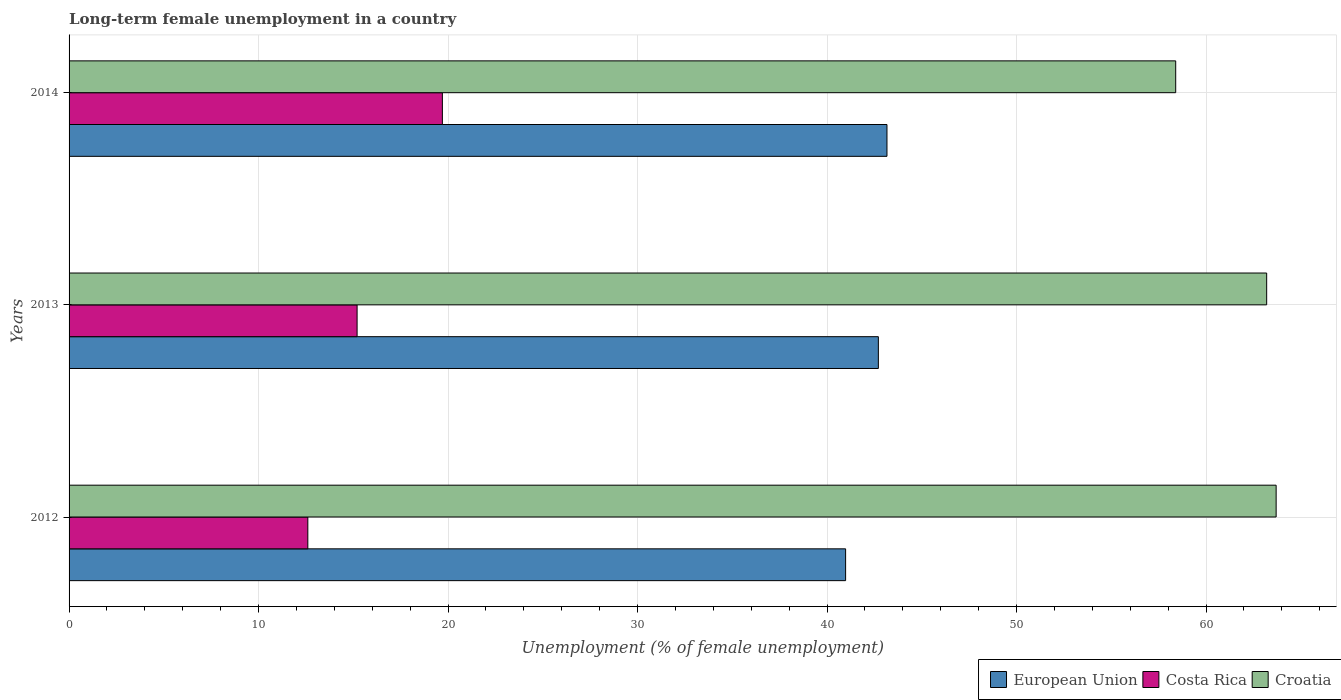How many different coloured bars are there?
Provide a short and direct response. 3. Are the number of bars per tick equal to the number of legend labels?
Provide a short and direct response. Yes. How many bars are there on the 1st tick from the top?
Your answer should be compact. 3. How many bars are there on the 3rd tick from the bottom?
Give a very brief answer. 3. What is the percentage of long-term unemployed female population in Croatia in 2014?
Make the answer very short. 58.4. Across all years, what is the maximum percentage of long-term unemployed female population in Costa Rica?
Provide a succinct answer. 19.7. Across all years, what is the minimum percentage of long-term unemployed female population in Costa Rica?
Provide a succinct answer. 12.6. In which year was the percentage of long-term unemployed female population in European Union maximum?
Offer a very short reply. 2014. What is the total percentage of long-term unemployed female population in Costa Rica in the graph?
Offer a very short reply. 47.5. What is the difference between the percentage of long-term unemployed female population in European Union in 2012 and that in 2013?
Provide a succinct answer. -1.73. What is the difference between the percentage of long-term unemployed female population in European Union in 2013 and the percentage of long-term unemployed female population in Croatia in 2012?
Your answer should be very brief. -20.99. What is the average percentage of long-term unemployed female population in European Union per year?
Provide a succinct answer. 42.28. In the year 2013, what is the difference between the percentage of long-term unemployed female population in Croatia and percentage of long-term unemployed female population in European Union?
Make the answer very short. 20.49. In how many years, is the percentage of long-term unemployed female population in Costa Rica greater than 2 %?
Offer a terse response. 3. What is the ratio of the percentage of long-term unemployed female population in European Union in 2012 to that in 2014?
Offer a terse response. 0.95. Is the percentage of long-term unemployed female population in Croatia in 2012 less than that in 2014?
Make the answer very short. No. Is the difference between the percentage of long-term unemployed female population in Croatia in 2012 and 2014 greater than the difference between the percentage of long-term unemployed female population in European Union in 2012 and 2014?
Your answer should be very brief. Yes. What is the difference between the highest and the second highest percentage of long-term unemployed female population in Costa Rica?
Give a very brief answer. 4.5. What is the difference between the highest and the lowest percentage of long-term unemployed female population in European Union?
Make the answer very short. 2.18. What does the 3rd bar from the top in 2013 represents?
Provide a short and direct response. European Union. Is it the case that in every year, the sum of the percentage of long-term unemployed female population in Croatia and percentage of long-term unemployed female population in European Union is greater than the percentage of long-term unemployed female population in Costa Rica?
Provide a succinct answer. Yes. What is the difference between two consecutive major ticks on the X-axis?
Offer a very short reply. 10. Does the graph contain any zero values?
Provide a succinct answer. No. Where does the legend appear in the graph?
Keep it short and to the point. Bottom right. How many legend labels are there?
Make the answer very short. 3. How are the legend labels stacked?
Make the answer very short. Horizontal. What is the title of the graph?
Provide a succinct answer. Long-term female unemployment in a country. Does "American Samoa" appear as one of the legend labels in the graph?
Offer a terse response. No. What is the label or title of the X-axis?
Keep it short and to the point. Unemployment (% of female unemployment). What is the Unemployment (% of female unemployment) in European Union in 2012?
Offer a very short reply. 40.98. What is the Unemployment (% of female unemployment) of Costa Rica in 2012?
Offer a very short reply. 12.6. What is the Unemployment (% of female unemployment) in Croatia in 2012?
Give a very brief answer. 63.7. What is the Unemployment (% of female unemployment) in European Union in 2013?
Provide a succinct answer. 42.71. What is the Unemployment (% of female unemployment) in Costa Rica in 2013?
Provide a succinct answer. 15.2. What is the Unemployment (% of female unemployment) of Croatia in 2013?
Ensure brevity in your answer.  63.2. What is the Unemployment (% of female unemployment) of European Union in 2014?
Provide a succinct answer. 43.16. What is the Unemployment (% of female unemployment) of Costa Rica in 2014?
Offer a terse response. 19.7. What is the Unemployment (% of female unemployment) in Croatia in 2014?
Your answer should be very brief. 58.4. Across all years, what is the maximum Unemployment (% of female unemployment) of European Union?
Your answer should be very brief. 43.16. Across all years, what is the maximum Unemployment (% of female unemployment) of Costa Rica?
Keep it short and to the point. 19.7. Across all years, what is the maximum Unemployment (% of female unemployment) in Croatia?
Give a very brief answer. 63.7. Across all years, what is the minimum Unemployment (% of female unemployment) in European Union?
Provide a succinct answer. 40.98. Across all years, what is the minimum Unemployment (% of female unemployment) in Costa Rica?
Provide a succinct answer. 12.6. Across all years, what is the minimum Unemployment (% of female unemployment) in Croatia?
Your response must be concise. 58.4. What is the total Unemployment (% of female unemployment) of European Union in the graph?
Keep it short and to the point. 126.85. What is the total Unemployment (% of female unemployment) of Costa Rica in the graph?
Offer a terse response. 47.5. What is the total Unemployment (% of female unemployment) in Croatia in the graph?
Provide a short and direct response. 185.3. What is the difference between the Unemployment (% of female unemployment) in European Union in 2012 and that in 2013?
Provide a short and direct response. -1.73. What is the difference between the Unemployment (% of female unemployment) of Costa Rica in 2012 and that in 2013?
Ensure brevity in your answer.  -2.6. What is the difference between the Unemployment (% of female unemployment) of European Union in 2012 and that in 2014?
Your response must be concise. -2.18. What is the difference between the Unemployment (% of female unemployment) in Costa Rica in 2012 and that in 2014?
Offer a terse response. -7.1. What is the difference between the Unemployment (% of female unemployment) of Croatia in 2012 and that in 2014?
Give a very brief answer. 5.3. What is the difference between the Unemployment (% of female unemployment) in European Union in 2013 and that in 2014?
Offer a very short reply. -0.45. What is the difference between the Unemployment (% of female unemployment) in Costa Rica in 2013 and that in 2014?
Offer a terse response. -4.5. What is the difference between the Unemployment (% of female unemployment) in Croatia in 2013 and that in 2014?
Provide a short and direct response. 4.8. What is the difference between the Unemployment (% of female unemployment) of European Union in 2012 and the Unemployment (% of female unemployment) of Costa Rica in 2013?
Your answer should be very brief. 25.78. What is the difference between the Unemployment (% of female unemployment) of European Union in 2012 and the Unemployment (% of female unemployment) of Croatia in 2013?
Offer a terse response. -22.22. What is the difference between the Unemployment (% of female unemployment) of Costa Rica in 2012 and the Unemployment (% of female unemployment) of Croatia in 2013?
Offer a terse response. -50.6. What is the difference between the Unemployment (% of female unemployment) in European Union in 2012 and the Unemployment (% of female unemployment) in Costa Rica in 2014?
Provide a succinct answer. 21.28. What is the difference between the Unemployment (% of female unemployment) of European Union in 2012 and the Unemployment (% of female unemployment) of Croatia in 2014?
Provide a short and direct response. -17.42. What is the difference between the Unemployment (% of female unemployment) of Costa Rica in 2012 and the Unemployment (% of female unemployment) of Croatia in 2014?
Your answer should be compact. -45.8. What is the difference between the Unemployment (% of female unemployment) in European Union in 2013 and the Unemployment (% of female unemployment) in Costa Rica in 2014?
Offer a terse response. 23.01. What is the difference between the Unemployment (% of female unemployment) in European Union in 2013 and the Unemployment (% of female unemployment) in Croatia in 2014?
Your response must be concise. -15.69. What is the difference between the Unemployment (% of female unemployment) in Costa Rica in 2013 and the Unemployment (% of female unemployment) in Croatia in 2014?
Make the answer very short. -43.2. What is the average Unemployment (% of female unemployment) in European Union per year?
Your answer should be very brief. 42.28. What is the average Unemployment (% of female unemployment) in Costa Rica per year?
Offer a very short reply. 15.83. What is the average Unemployment (% of female unemployment) of Croatia per year?
Your answer should be compact. 61.77. In the year 2012, what is the difference between the Unemployment (% of female unemployment) in European Union and Unemployment (% of female unemployment) in Costa Rica?
Provide a short and direct response. 28.38. In the year 2012, what is the difference between the Unemployment (% of female unemployment) in European Union and Unemployment (% of female unemployment) in Croatia?
Your answer should be very brief. -22.72. In the year 2012, what is the difference between the Unemployment (% of female unemployment) in Costa Rica and Unemployment (% of female unemployment) in Croatia?
Provide a short and direct response. -51.1. In the year 2013, what is the difference between the Unemployment (% of female unemployment) in European Union and Unemployment (% of female unemployment) in Costa Rica?
Ensure brevity in your answer.  27.51. In the year 2013, what is the difference between the Unemployment (% of female unemployment) of European Union and Unemployment (% of female unemployment) of Croatia?
Offer a terse response. -20.49. In the year 2013, what is the difference between the Unemployment (% of female unemployment) of Costa Rica and Unemployment (% of female unemployment) of Croatia?
Give a very brief answer. -48. In the year 2014, what is the difference between the Unemployment (% of female unemployment) of European Union and Unemployment (% of female unemployment) of Costa Rica?
Your answer should be very brief. 23.46. In the year 2014, what is the difference between the Unemployment (% of female unemployment) of European Union and Unemployment (% of female unemployment) of Croatia?
Offer a very short reply. -15.24. In the year 2014, what is the difference between the Unemployment (% of female unemployment) of Costa Rica and Unemployment (% of female unemployment) of Croatia?
Your answer should be compact. -38.7. What is the ratio of the Unemployment (% of female unemployment) in European Union in 2012 to that in 2013?
Keep it short and to the point. 0.96. What is the ratio of the Unemployment (% of female unemployment) of Costa Rica in 2012 to that in 2013?
Give a very brief answer. 0.83. What is the ratio of the Unemployment (% of female unemployment) in Croatia in 2012 to that in 2013?
Ensure brevity in your answer.  1.01. What is the ratio of the Unemployment (% of female unemployment) of European Union in 2012 to that in 2014?
Keep it short and to the point. 0.95. What is the ratio of the Unemployment (% of female unemployment) in Costa Rica in 2012 to that in 2014?
Offer a very short reply. 0.64. What is the ratio of the Unemployment (% of female unemployment) in Croatia in 2012 to that in 2014?
Ensure brevity in your answer.  1.09. What is the ratio of the Unemployment (% of female unemployment) of European Union in 2013 to that in 2014?
Your answer should be compact. 0.99. What is the ratio of the Unemployment (% of female unemployment) of Costa Rica in 2013 to that in 2014?
Provide a succinct answer. 0.77. What is the ratio of the Unemployment (% of female unemployment) of Croatia in 2013 to that in 2014?
Your answer should be very brief. 1.08. What is the difference between the highest and the second highest Unemployment (% of female unemployment) in European Union?
Offer a terse response. 0.45. What is the difference between the highest and the second highest Unemployment (% of female unemployment) of Croatia?
Offer a terse response. 0.5. What is the difference between the highest and the lowest Unemployment (% of female unemployment) in European Union?
Ensure brevity in your answer.  2.18. What is the difference between the highest and the lowest Unemployment (% of female unemployment) of Costa Rica?
Offer a very short reply. 7.1. 